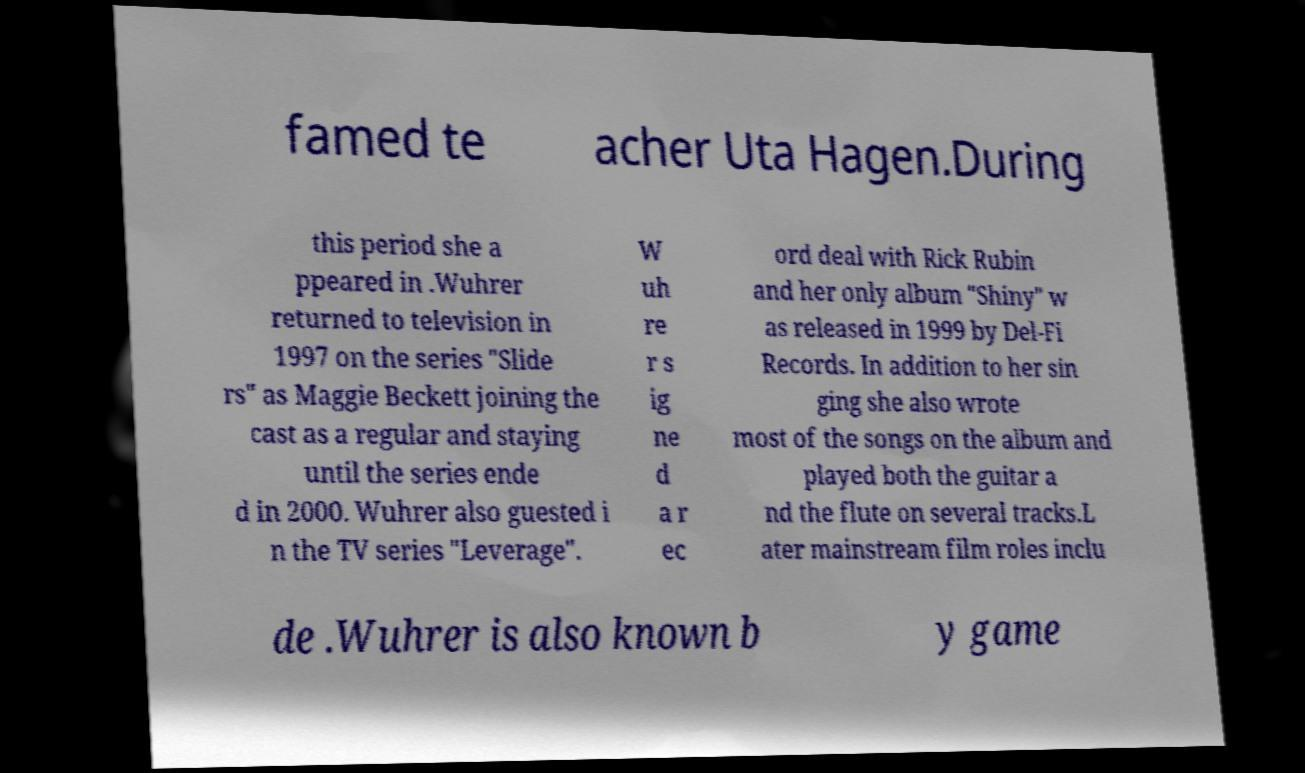Can you accurately transcribe the text from the provided image for me? famed te acher Uta Hagen.During this period she a ppeared in .Wuhrer returned to television in 1997 on the series "Slide rs" as Maggie Beckett joining the cast as a regular and staying until the series ende d in 2000. Wuhrer also guested i n the TV series "Leverage". W uh re r s ig ne d a r ec ord deal with Rick Rubin and her only album "Shiny" w as released in 1999 by Del-Fi Records. In addition to her sin ging she also wrote most of the songs on the album and played both the guitar a nd the flute on several tracks.L ater mainstream film roles inclu de .Wuhrer is also known b y game 